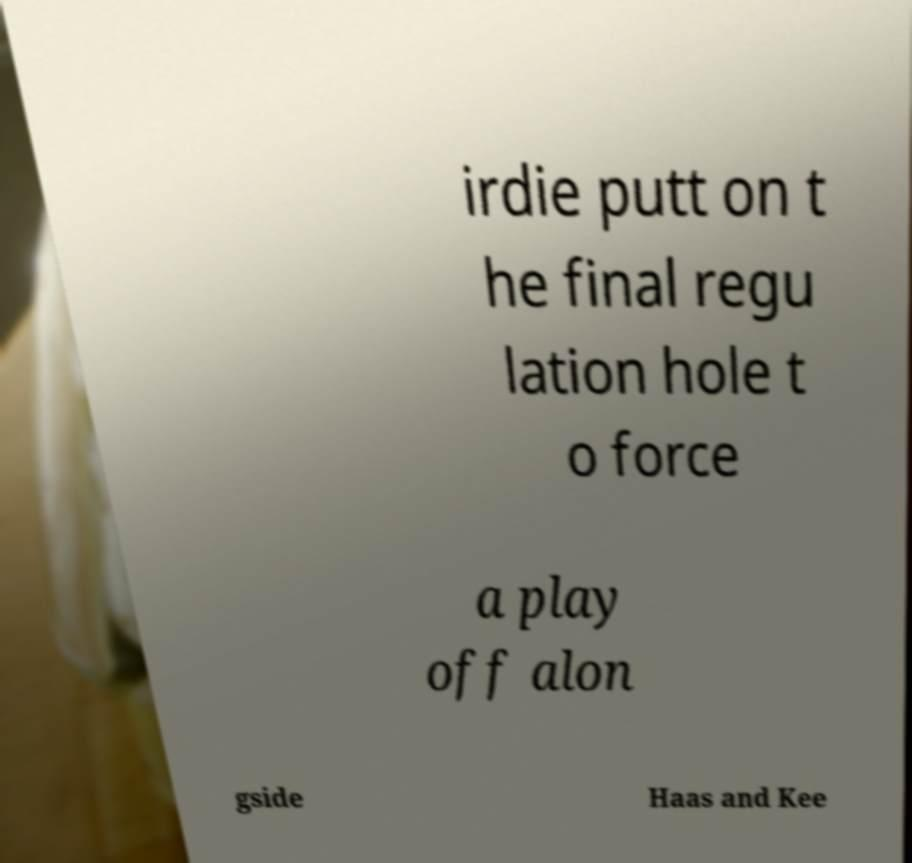Please read and relay the text visible in this image. What does it say? irdie putt on t he final regu lation hole t o force a play off alon gside Haas and Kee 